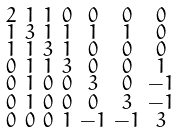<formula> <loc_0><loc_0><loc_500><loc_500>\begin{smallmatrix} 2 & 1 & 1 & 0 & 0 & 0 & 0 \\ 1 & 3 & 1 & 1 & 1 & 1 & 0 \\ 1 & 1 & 3 & 1 & 0 & 0 & 0 \\ 0 & 1 & 1 & 3 & 0 & 0 & 1 \\ 0 & 1 & 0 & 0 & 3 & 0 & - 1 \\ 0 & 1 & 0 & 0 & 0 & 3 & - 1 \\ 0 & 0 & 0 & 1 & - 1 & - 1 & 3 \end{smallmatrix}</formula> 